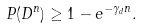Convert formula to latex. <formula><loc_0><loc_0><loc_500><loc_500>P ( D ^ { n } ) \geq 1 - e ^ { - \gamma _ { d } n } .</formula> 